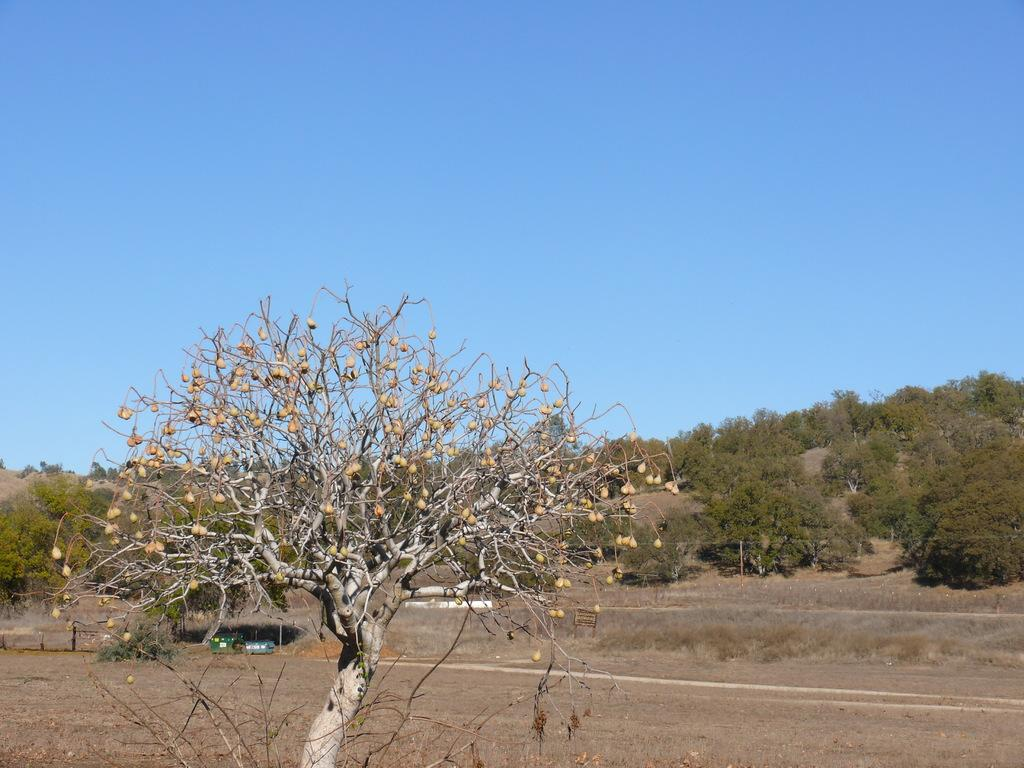What is the main object in the image? There is a tree in the image. What is visible behind the tree? There is a surface visible behind the tree. Are there any other trees in the image? Yes, there are trees in the distance. What can be seen in the sky in the image? The sky is visible in the image. What type of window can be seen in the tree in the image? There is no window present in the tree or the image. What class is being taught in the tree in the image? There is no class being taught in the tree or the image. 